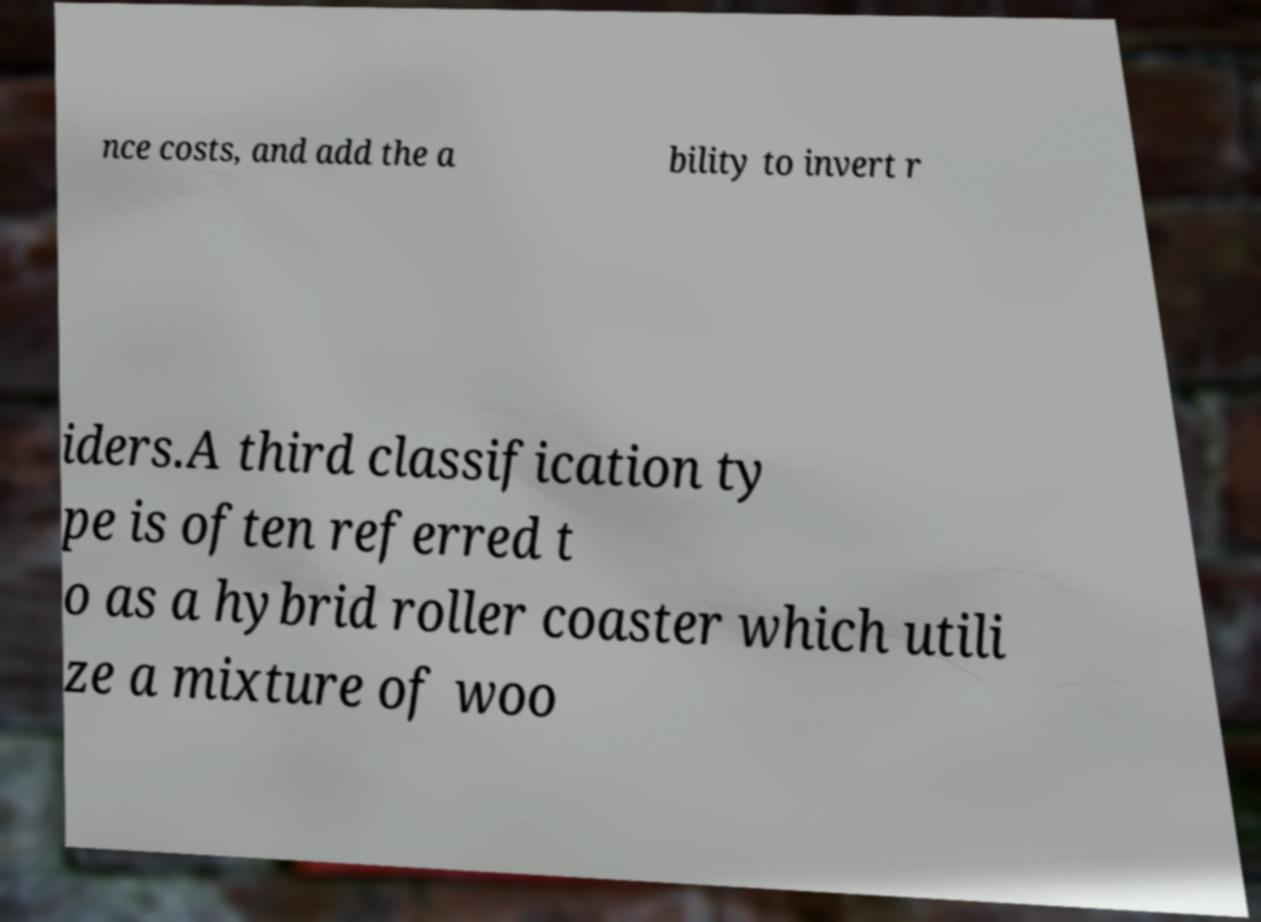What messages or text are displayed in this image? I need them in a readable, typed format. nce costs, and add the a bility to invert r iders.A third classification ty pe is often referred t o as a hybrid roller coaster which utili ze a mixture of woo 